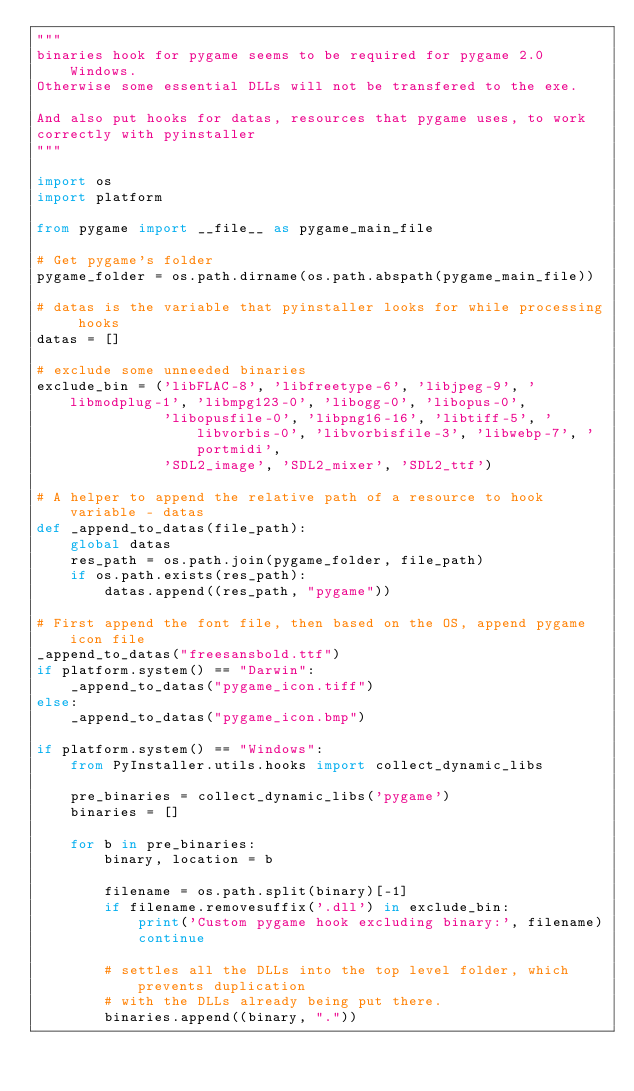Convert code to text. <code><loc_0><loc_0><loc_500><loc_500><_Python_>"""
binaries hook for pygame seems to be required for pygame 2.0 Windows.
Otherwise some essential DLLs will not be transfered to the exe.

And also put hooks for datas, resources that pygame uses, to work 
correctly with pyinstaller
"""

import os
import platform

from pygame import __file__ as pygame_main_file

# Get pygame's folder
pygame_folder = os.path.dirname(os.path.abspath(pygame_main_file))

# datas is the variable that pyinstaller looks for while processing hooks
datas = []

# exclude some unneeded binaries
exclude_bin = ('libFLAC-8', 'libfreetype-6', 'libjpeg-9', 'libmodplug-1', 'libmpg123-0', 'libogg-0', 'libopus-0',
               'libopusfile-0', 'libpng16-16', 'libtiff-5', 'libvorbis-0', 'libvorbisfile-3', 'libwebp-7', 'portmidi',
               'SDL2_image', 'SDL2_mixer', 'SDL2_ttf')

# A helper to append the relative path of a resource to hook variable - datas
def _append_to_datas(file_path):
    global datas
    res_path = os.path.join(pygame_folder, file_path)
    if os.path.exists(res_path):
        datas.append((res_path, "pygame"))

# First append the font file, then based on the OS, append pygame icon file
_append_to_datas("freesansbold.ttf")
if platform.system() == "Darwin":
    _append_to_datas("pygame_icon.tiff")
else:
    _append_to_datas("pygame_icon.bmp")

if platform.system() == "Windows": 
    from PyInstaller.utils.hooks import collect_dynamic_libs

    pre_binaries = collect_dynamic_libs('pygame')
    binaries = []

    for b in pre_binaries:
        binary, location = b

        filename = os.path.split(binary)[-1]
        if filename.removesuffix('.dll') in exclude_bin:
            print('Custom pygame hook excluding binary:', filename)
            continue

        # settles all the DLLs into the top level folder, which prevents duplication
        # with the DLLs already being put there.
        binaries.append((binary, "."))
</code> 